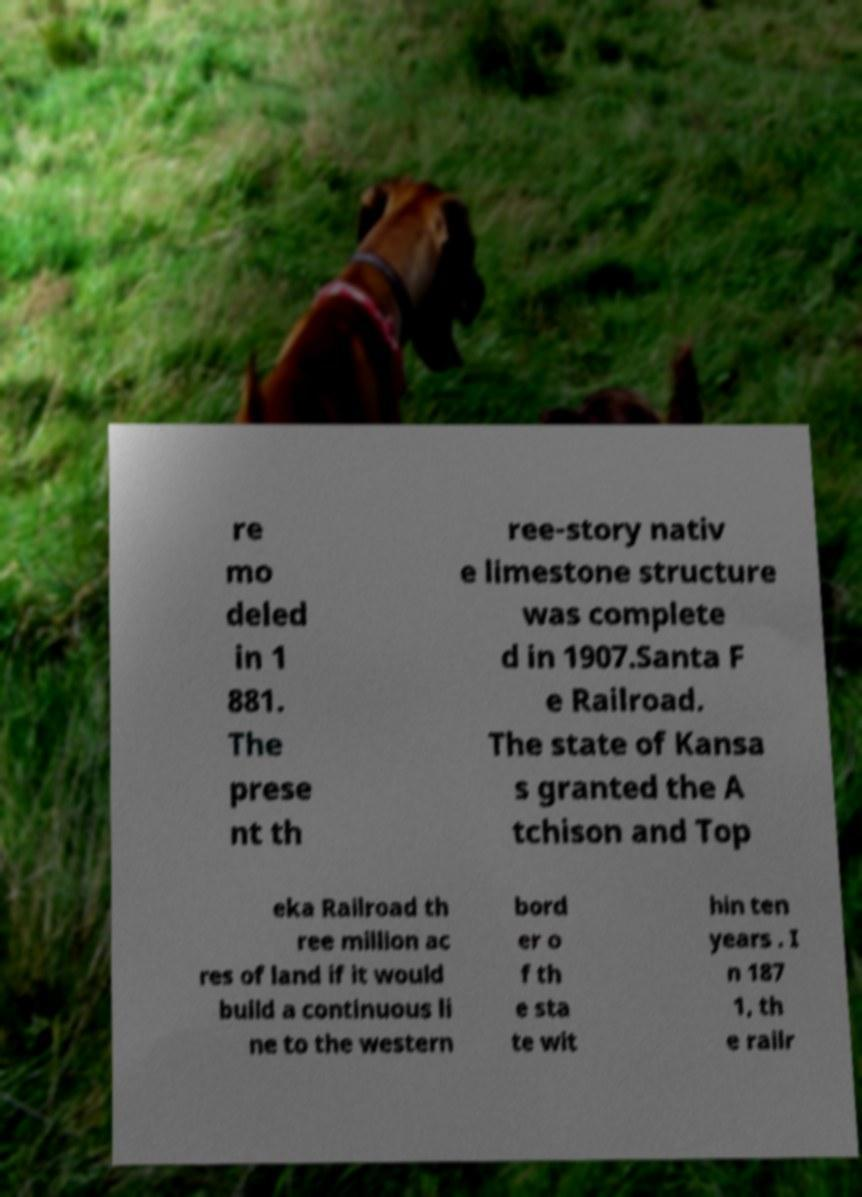Can you read and provide the text displayed in the image?This photo seems to have some interesting text. Can you extract and type it out for me? re mo deled in 1 881. The prese nt th ree-story nativ e limestone structure was complete d in 1907.Santa F e Railroad. The state of Kansa s granted the A tchison and Top eka Railroad th ree million ac res of land if it would build a continuous li ne to the western bord er o f th e sta te wit hin ten years . I n 187 1, th e railr 